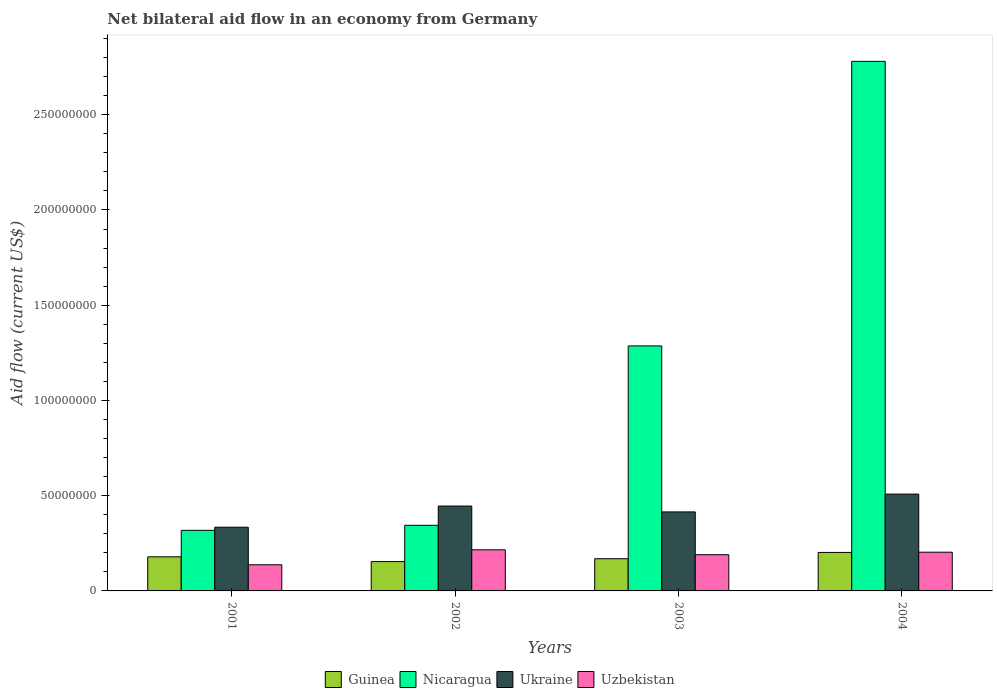How many different coloured bars are there?
Keep it short and to the point. 4. How many groups of bars are there?
Provide a succinct answer. 4. Are the number of bars on each tick of the X-axis equal?
Keep it short and to the point. Yes. How many bars are there on the 4th tick from the right?
Provide a succinct answer. 4. What is the label of the 3rd group of bars from the left?
Provide a short and direct response. 2003. What is the net bilateral aid flow in Nicaragua in 2003?
Provide a short and direct response. 1.29e+08. Across all years, what is the maximum net bilateral aid flow in Nicaragua?
Ensure brevity in your answer.  2.78e+08. Across all years, what is the minimum net bilateral aid flow in Nicaragua?
Your answer should be compact. 3.18e+07. What is the total net bilateral aid flow in Guinea in the graph?
Give a very brief answer. 7.04e+07. What is the difference between the net bilateral aid flow in Ukraine in 2001 and that in 2003?
Keep it short and to the point. -8.03e+06. What is the difference between the net bilateral aid flow in Uzbekistan in 2003 and the net bilateral aid flow in Nicaragua in 2002?
Your answer should be very brief. -1.54e+07. What is the average net bilateral aid flow in Uzbekistan per year?
Your response must be concise. 1.87e+07. In the year 2001, what is the difference between the net bilateral aid flow in Guinea and net bilateral aid flow in Nicaragua?
Your response must be concise. -1.39e+07. What is the ratio of the net bilateral aid flow in Nicaragua in 2001 to that in 2004?
Give a very brief answer. 0.11. Is the net bilateral aid flow in Ukraine in 2001 less than that in 2002?
Your response must be concise. Yes. Is the difference between the net bilateral aid flow in Guinea in 2001 and 2004 greater than the difference between the net bilateral aid flow in Nicaragua in 2001 and 2004?
Keep it short and to the point. Yes. What is the difference between the highest and the second highest net bilateral aid flow in Uzbekistan?
Offer a very short reply. 1.24e+06. What is the difference between the highest and the lowest net bilateral aid flow in Uzbekistan?
Your answer should be very brief. 7.84e+06. In how many years, is the net bilateral aid flow in Guinea greater than the average net bilateral aid flow in Guinea taken over all years?
Your answer should be very brief. 2. Is the sum of the net bilateral aid flow in Ukraine in 2003 and 2004 greater than the maximum net bilateral aid flow in Uzbekistan across all years?
Make the answer very short. Yes. What does the 2nd bar from the left in 2003 represents?
Your answer should be very brief. Nicaragua. What does the 4th bar from the right in 2004 represents?
Make the answer very short. Guinea. Is it the case that in every year, the sum of the net bilateral aid flow in Guinea and net bilateral aid flow in Ukraine is greater than the net bilateral aid flow in Nicaragua?
Ensure brevity in your answer.  No. Are the values on the major ticks of Y-axis written in scientific E-notation?
Your answer should be compact. No. Does the graph contain grids?
Provide a short and direct response. No. What is the title of the graph?
Keep it short and to the point. Net bilateral aid flow in an economy from Germany. Does "Armenia" appear as one of the legend labels in the graph?
Give a very brief answer. No. What is the Aid flow (current US$) of Guinea in 2001?
Provide a short and direct response. 1.79e+07. What is the Aid flow (current US$) in Nicaragua in 2001?
Your answer should be compact. 3.18e+07. What is the Aid flow (current US$) in Ukraine in 2001?
Offer a terse response. 3.34e+07. What is the Aid flow (current US$) of Uzbekistan in 2001?
Your answer should be compact. 1.37e+07. What is the Aid flow (current US$) in Guinea in 2002?
Offer a terse response. 1.54e+07. What is the Aid flow (current US$) of Nicaragua in 2002?
Make the answer very short. 3.44e+07. What is the Aid flow (current US$) of Ukraine in 2002?
Give a very brief answer. 4.46e+07. What is the Aid flow (current US$) in Uzbekistan in 2002?
Your answer should be compact. 2.16e+07. What is the Aid flow (current US$) in Guinea in 2003?
Provide a succinct answer. 1.69e+07. What is the Aid flow (current US$) in Nicaragua in 2003?
Your answer should be very brief. 1.29e+08. What is the Aid flow (current US$) in Ukraine in 2003?
Keep it short and to the point. 4.15e+07. What is the Aid flow (current US$) in Uzbekistan in 2003?
Provide a short and direct response. 1.90e+07. What is the Aid flow (current US$) in Guinea in 2004?
Your answer should be very brief. 2.02e+07. What is the Aid flow (current US$) of Nicaragua in 2004?
Offer a very short reply. 2.78e+08. What is the Aid flow (current US$) of Ukraine in 2004?
Your answer should be compact. 5.08e+07. What is the Aid flow (current US$) in Uzbekistan in 2004?
Provide a succinct answer. 2.03e+07. Across all years, what is the maximum Aid flow (current US$) in Guinea?
Make the answer very short. 2.02e+07. Across all years, what is the maximum Aid flow (current US$) of Nicaragua?
Your answer should be compact. 2.78e+08. Across all years, what is the maximum Aid flow (current US$) of Ukraine?
Make the answer very short. 5.08e+07. Across all years, what is the maximum Aid flow (current US$) of Uzbekistan?
Give a very brief answer. 2.16e+07. Across all years, what is the minimum Aid flow (current US$) in Guinea?
Offer a very short reply. 1.54e+07. Across all years, what is the minimum Aid flow (current US$) of Nicaragua?
Your answer should be very brief. 3.18e+07. Across all years, what is the minimum Aid flow (current US$) of Ukraine?
Offer a very short reply. 3.34e+07. Across all years, what is the minimum Aid flow (current US$) in Uzbekistan?
Provide a succinct answer. 1.37e+07. What is the total Aid flow (current US$) of Guinea in the graph?
Offer a terse response. 7.04e+07. What is the total Aid flow (current US$) of Nicaragua in the graph?
Ensure brevity in your answer.  4.73e+08. What is the total Aid flow (current US$) of Ukraine in the graph?
Give a very brief answer. 1.70e+08. What is the total Aid flow (current US$) in Uzbekistan in the graph?
Make the answer very short. 7.46e+07. What is the difference between the Aid flow (current US$) in Guinea in 2001 and that in 2002?
Offer a very short reply. 2.50e+06. What is the difference between the Aid flow (current US$) in Nicaragua in 2001 and that in 2002?
Give a very brief answer. -2.64e+06. What is the difference between the Aid flow (current US$) of Ukraine in 2001 and that in 2002?
Your answer should be compact. -1.11e+07. What is the difference between the Aid flow (current US$) in Uzbekistan in 2001 and that in 2002?
Provide a short and direct response. -7.84e+06. What is the difference between the Aid flow (current US$) of Nicaragua in 2001 and that in 2003?
Ensure brevity in your answer.  -9.68e+07. What is the difference between the Aid flow (current US$) in Ukraine in 2001 and that in 2003?
Offer a very short reply. -8.03e+06. What is the difference between the Aid flow (current US$) in Uzbekistan in 2001 and that in 2003?
Provide a short and direct response. -5.28e+06. What is the difference between the Aid flow (current US$) of Guinea in 2001 and that in 2004?
Keep it short and to the point. -2.31e+06. What is the difference between the Aid flow (current US$) in Nicaragua in 2001 and that in 2004?
Your answer should be very brief. -2.46e+08. What is the difference between the Aid flow (current US$) in Ukraine in 2001 and that in 2004?
Offer a terse response. -1.74e+07. What is the difference between the Aid flow (current US$) in Uzbekistan in 2001 and that in 2004?
Provide a succinct answer. -6.60e+06. What is the difference between the Aid flow (current US$) in Guinea in 2002 and that in 2003?
Provide a short and direct response. -1.50e+06. What is the difference between the Aid flow (current US$) in Nicaragua in 2002 and that in 2003?
Provide a succinct answer. -9.42e+07. What is the difference between the Aid flow (current US$) of Ukraine in 2002 and that in 2003?
Ensure brevity in your answer.  3.08e+06. What is the difference between the Aid flow (current US$) in Uzbekistan in 2002 and that in 2003?
Offer a very short reply. 2.56e+06. What is the difference between the Aid flow (current US$) of Guinea in 2002 and that in 2004?
Give a very brief answer. -4.81e+06. What is the difference between the Aid flow (current US$) of Nicaragua in 2002 and that in 2004?
Your answer should be very brief. -2.44e+08. What is the difference between the Aid flow (current US$) in Ukraine in 2002 and that in 2004?
Give a very brief answer. -6.28e+06. What is the difference between the Aid flow (current US$) in Uzbekistan in 2002 and that in 2004?
Provide a succinct answer. 1.24e+06. What is the difference between the Aid flow (current US$) of Guinea in 2003 and that in 2004?
Make the answer very short. -3.31e+06. What is the difference between the Aid flow (current US$) of Nicaragua in 2003 and that in 2004?
Your answer should be compact. -1.49e+08. What is the difference between the Aid flow (current US$) in Ukraine in 2003 and that in 2004?
Offer a terse response. -9.36e+06. What is the difference between the Aid flow (current US$) in Uzbekistan in 2003 and that in 2004?
Provide a short and direct response. -1.32e+06. What is the difference between the Aid flow (current US$) in Guinea in 2001 and the Aid flow (current US$) in Nicaragua in 2002?
Offer a very short reply. -1.66e+07. What is the difference between the Aid flow (current US$) in Guinea in 2001 and the Aid flow (current US$) in Ukraine in 2002?
Provide a short and direct response. -2.67e+07. What is the difference between the Aid flow (current US$) in Guinea in 2001 and the Aid flow (current US$) in Uzbekistan in 2002?
Your answer should be compact. -3.67e+06. What is the difference between the Aid flow (current US$) in Nicaragua in 2001 and the Aid flow (current US$) in Ukraine in 2002?
Offer a terse response. -1.28e+07. What is the difference between the Aid flow (current US$) in Nicaragua in 2001 and the Aid flow (current US$) in Uzbekistan in 2002?
Your answer should be very brief. 1.02e+07. What is the difference between the Aid flow (current US$) in Ukraine in 2001 and the Aid flow (current US$) in Uzbekistan in 2002?
Your answer should be very brief. 1.19e+07. What is the difference between the Aid flow (current US$) of Guinea in 2001 and the Aid flow (current US$) of Nicaragua in 2003?
Offer a terse response. -1.11e+08. What is the difference between the Aid flow (current US$) of Guinea in 2001 and the Aid flow (current US$) of Ukraine in 2003?
Make the answer very short. -2.36e+07. What is the difference between the Aid flow (current US$) in Guinea in 2001 and the Aid flow (current US$) in Uzbekistan in 2003?
Your response must be concise. -1.11e+06. What is the difference between the Aid flow (current US$) of Nicaragua in 2001 and the Aid flow (current US$) of Ukraine in 2003?
Offer a terse response. -9.67e+06. What is the difference between the Aid flow (current US$) of Nicaragua in 2001 and the Aid flow (current US$) of Uzbekistan in 2003?
Your answer should be compact. 1.28e+07. What is the difference between the Aid flow (current US$) of Ukraine in 2001 and the Aid flow (current US$) of Uzbekistan in 2003?
Offer a terse response. 1.44e+07. What is the difference between the Aid flow (current US$) of Guinea in 2001 and the Aid flow (current US$) of Nicaragua in 2004?
Your answer should be compact. -2.60e+08. What is the difference between the Aid flow (current US$) of Guinea in 2001 and the Aid flow (current US$) of Ukraine in 2004?
Your answer should be compact. -3.29e+07. What is the difference between the Aid flow (current US$) of Guinea in 2001 and the Aid flow (current US$) of Uzbekistan in 2004?
Provide a short and direct response. -2.43e+06. What is the difference between the Aid flow (current US$) of Nicaragua in 2001 and the Aid flow (current US$) of Ukraine in 2004?
Give a very brief answer. -1.90e+07. What is the difference between the Aid flow (current US$) of Nicaragua in 2001 and the Aid flow (current US$) of Uzbekistan in 2004?
Offer a terse response. 1.15e+07. What is the difference between the Aid flow (current US$) of Ukraine in 2001 and the Aid flow (current US$) of Uzbekistan in 2004?
Your answer should be compact. 1.31e+07. What is the difference between the Aid flow (current US$) in Guinea in 2002 and the Aid flow (current US$) in Nicaragua in 2003?
Provide a succinct answer. -1.13e+08. What is the difference between the Aid flow (current US$) of Guinea in 2002 and the Aid flow (current US$) of Ukraine in 2003?
Provide a short and direct response. -2.61e+07. What is the difference between the Aid flow (current US$) in Guinea in 2002 and the Aid flow (current US$) in Uzbekistan in 2003?
Offer a terse response. -3.61e+06. What is the difference between the Aid flow (current US$) in Nicaragua in 2002 and the Aid flow (current US$) in Ukraine in 2003?
Keep it short and to the point. -7.03e+06. What is the difference between the Aid flow (current US$) in Nicaragua in 2002 and the Aid flow (current US$) in Uzbekistan in 2003?
Offer a very short reply. 1.54e+07. What is the difference between the Aid flow (current US$) in Ukraine in 2002 and the Aid flow (current US$) in Uzbekistan in 2003?
Give a very brief answer. 2.56e+07. What is the difference between the Aid flow (current US$) of Guinea in 2002 and the Aid flow (current US$) of Nicaragua in 2004?
Provide a short and direct response. -2.63e+08. What is the difference between the Aid flow (current US$) in Guinea in 2002 and the Aid flow (current US$) in Ukraine in 2004?
Ensure brevity in your answer.  -3.54e+07. What is the difference between the Aid flow (current US$) of Guinea in 2002 and the Aid flow (current US$) of Uzbekistan in 2004?
Give a very brief answer. -4.93e+06. What is the difference between the Aid flow (current US$) of Nicaragua in 2002 and the Aid flow (current US$) of Ukraine in 2004?
Make the answer very short. -1.64e+07. What is the difference between the Aid flow (current US$) of Nicaragua in 2002 and the Aid flow (current US$) of Uzbekistan in 2004?
Your answer should be very brief. 1.41e+07. What is the difference between the Aid flow (current US$) of Ukraine in 2002 and the Aid flow (current US$) of Uzbekistan in 2004?
Offer a terse response. 2.42e+07. What is the difference between the Aid flow (current US$) of Guinea in 2003 and the Aid flow (current US$) of Nicaragua in 2004?
Keep it short and to the point. -2.61e+08. What is the difference between the Aid flow (current US$) in Guinea in 2003 and the Aid flow (current US$) in Ukraine in 2004?
Offer a terse response. -3.39e+07. What is the difference between the Aid flow (current US$) of Guinea in 2003 and the Aid flow (current US$) of Uzbekistan in 2004?
Provide a short and direct response. -3.43e+06. What is the difference between the Aid flow (current US$) in Nicaragua in 2003 and the Aid flow (current US$) in Ukraine in 2004?
Make the answer very short. 7.78e+07. What is the difference between the Aid flow (current US$) of Nicaragua in 2003 and the Aid flow (current US$) of Uzbekistan in 2004?
Your answer should be very brief. 1.08e+08. What is the difference between the Aid flow (current US$) of Ukraine in 2003 and the Aid flow (current US$) of Uzbekistan in 2004?
Your answer should be very brief. 2.12e+07. What is the average Aid flow (current US$) in Guinea per year?
Your answer should be very brief. 1.76e+07. What is the average Aid flow (current US$) in Nicaragua per year?
Offer a very short reply. 1.18e+08. What is the average Aid flow (current US$) in Ukraine per year?
Your answer should be very brief. 4.26e+07. What is the average Aid flow (current US$) of Uzbekistan per year?
Offer a very short reply. 1.87e+07. In the year 2001, what is the difference between the Aid flow (current US$) of Guinea and Aid flow (current US$) of Nicaragua?
Provide a succinct answer. -1.39e+07. In the year 2001, what is the difference between the Aid flow (current US$) in Guinea and Aid flow (current US$) in Ukraine?
Offer a terse response. -1.56e+07. In the year 2001, what is the difference between the Aid flow (current US$) in Guinea and Aid flow (current US$) in Uzbekistan?
Ensure brevity in your answer.  4.17e+06. In the year 2001, what is the difference between the Aid flow (current US$) of Nicaragua and Aid flow (current US$) of Ukraine?
Give a very brief answer. -1.64e+06. In the year 2001, what is the difference between the Aid flow (current US$) of Nicaragua and Aid flow (current US$) of Uzbekistan?
Ensure brevity in your answer.  1.81e+07. In the year 2001, what is the difference between the Aid flow (current US$) of Ukraine and Aid flow (current US$) of Uzbekistan?
Provide a short and direct response. 1.97e+07. In the year 2002, what is the difference between the Aid flow (current US$) of Guinea and Aid flow (current US$) of Nicaragua?
Your answer should be very brief. -1.90e+07. In the year 2002, what is the difference between the Aid flow (current US$) in Guinea and Aid flow (current US$) in Ukraine?
Your answer should be compact. -2.92e+07. In the year 2002, what is the difference between the Aid flow (current US$) of Guinea and Aid flow (current US$) of Uzbekistan?
Give a very brief answer. -6.17e+06. In the year 2002, what is the difference between the Aid flow (current US$) in Nicaragua and Aid flow (current US$) in Ukraine?
Keep it short and to the point. -1.01e+07. In the year 2002, what is the difference between the Aid flow (current US$) in Nicaragua and Aid flow (current US$) in Uzbekistan?
Offer a very short reply. 1.29e+07. In the year 2002, what is the difference between the Aid flow (current US$) in Ukraine and Aid flow (current US$) in Uzbekistan?
Provide a succinct answer. 2.30e+07. In the year 2003, what is the difference between the Aid flow (current US$) in Guinea and Aid flow (current US$) in Nicaragua?
Ensure brevity in your answer.  -1.12e+08. In the year 2003, what is the difference between the Aid flow (current US$) of Guinea and Aid flow (current US$) of Ukraine?
Provide a short and direct response. -2.46e+07. In the year 2003, what is the difference between the Aid flow (current US$) in Guinea and Aid flow (current US$) in Uzbekistan?
Provide a succinct answer. -2.11e+06. In the year 2003, what is the difference between the Aid flow (current US$) of Nicaragua and Aid flow (current US$) of Ukraine?
Provide a succinct answer. 8.72e+07. In the year 2003, what is the difference between the Aid flow (current US$) in Nicaragua and Aid flow (current US$) in Uzbekistan?
Provide a short and direct response. 1.10e+08. In the year 2003, what is the difference between the Aid flow (current US$) in Ukraine and Aid flow (current US$) in Uzbekistan?
Provide a short and direct response. 2.25e+07. In the year 2004, what is the difference between the Aid flow (current US$) in Guinea and Aid flow (current US$) in Nicaragua?
Provide a short and direct response. -2.58e+08. In the year 2004, what is the difference between the Aid flow (current US$) of Guinea and Aid flow (current US$) of Ukraine?
Give a very brief answer. -3.06e+07. In the year 2004, what is the difference between the Aid flow (current US$) in Guinea and Aid flow (current US$) in Uzbekistan?
Provide a succinct answer. -1.20e+05. In the year 2004, what is the difference between the Aid flow (current US$) in Nicaragua and Aid flow (current US$) in Ukraine?
Your response must be concise. 2.27e+08. In the year 2004, what is the difference between the Aid flow (current US$) of Nicaragua and Aid flow (current US$) of Uzbekistan?
Ensure brevity in your answer.  2.58e+08. In the year 2004, what is the difference between the Aid flow (current US$) of Ukraine and Aid flow (current US$) of Uzbekistan?
Keep it short and to the point. 3.05e+07. What is the ratio of the Aid flow (current US$) of Guinea in 2001 to that in 2002?
Your response must be concise. 1.16. What is the ratio of the Aid flow (current US$) in Nicaragua in 2001 to that in 2002?
Ensure brevity in your answer.  0.92. What is the ratio of the Aid flow (current US$) of Ukraine in 2001 to that in 2002?
Your response must be concise. 0.75. What is the ratio of the Aid flow (current US$) in Uzbekistan in 2001 to that in 2002?
Provide a short and direct response. 0.64. What is the ratio of the Aid flow (current US$) of Guinea in 2001 to that in 2003?
Offer a terse response. 1.06. What is the ratio of the Aid flow (current US$) of Nicaragua in 2001 to that in 2003?
Make the answer very short. 0.25. What is the ratio of the Aid flow (current US$) in Ukraine in 2001 to that in 2003?
Keep it short and to the point. 0.81. What is the ratio of the Aid flow (current US$) in Uzbekistan in 2001 to that in 2003?
Keep it short and to the point. 0.72. What is the ratio of the Aid flow (current US$) of Guinea in 2001 to that in 2004?
Your response must be concise. 0.89. What is the ratio of the Aid flow (current US$) in Nicaragua in 2001 to that in 2004?
Ensure brevity in your answer.  0.11. What is the ratio of the Aid flow (current US$) in Ukraine in 2001 to that in 2004?
Offer a terse response. 0.66. What is the ratio of the Aid flow (current US$) in Uzbekistan in 2001 to that in 2004?
Your response must be concise. 0.68. What is the ratio of the Aid flow (current US$) of Guinea in 2002 to that in 2003?
Your answer should be very brief. 0.91. What is the ratio of the Aid flow (current US$) of Nicaragua in 2002 to that in 2003?
Make the answer very short. 0.27. What is the ratio of the Aid flow (current US$) of Ukraine in 2002 to that in 2003?
Your answer should be compact. 1.07. What is the ratio of the Aid flow (current US$) in Uzbekistan in 2002 to that in 2003?
Offer a terse response. 1.13. What is the ratio of the Aid flow (current US$) of Guinea in 2002 to that in 2004?
Ensure brevity in your answer.  0.76. What is the ratio of the Aid flow (current US$) in Nicaragua in 2002 to that in 2004?
Your answer should be compact. 0.12. What is the ratio of the Aid flow (current US$) in Ukraine in 2002 to that in 2004?
Your answer should be compact. 0.88. What is the ratio of the Aid flow (current US$) in Uzbekistan in 2002 to that in 2004?
Provide a succinct answer. 1.06. What is the ratio of the Aid flow (current US$) of Guinea in 2003 to that in 2004?
Give a very brief answer. 0.84. What is the ratio of the Aid flow (current US$) in Nicaragua in 2003 to that in 2004?
Offer a very short reply. 0.46. What is the ratio of the Aid flow (current US$) in Ukraine in 2003 to that in 2004?
Provide a short and direct response. 0.82. What is the ratio of the Aid flow (current US$) of Uzbekistan in 2003 to that in 2004?
Keep it short and to the point. 0.94. What is the difference between the highest and the second highest Aid flow (current US$) of Guinea?
Give a very brief answer. 2.31e+06. What is the difference between the highest and the second highest Aid flow (current US$) in Nicaragua?
Provide a short and direct response. 1.49e+08. What is the difference between the highest and the second highest Aid flow (current US$) in Ukraine?
Make the answer very short. 6.28e+06. What is the difference between the highest and the second highest Aid flow (current US$) in Uzbekistan?
Your answer should be very brief. 1.24e+06. What is the difference between the highest and the lowest Aid flow (current US$) of Guinea?
Your answer should be very brief. 4.81e+06. What is the difference between the highest and the lowest Aid flow (current US$) in Nicaragua?
Keep it short and to the point. 2.46e+08. What is the difference between the highest and the lowest Aid flow (current US$) in Ukraine?
Your answer should be very brief. 1.74e+07. What is the difference between the highest and the lowest Aid flow (current US$) in Uzbekistan?
Your answer should be compact. 7.84e+06. 